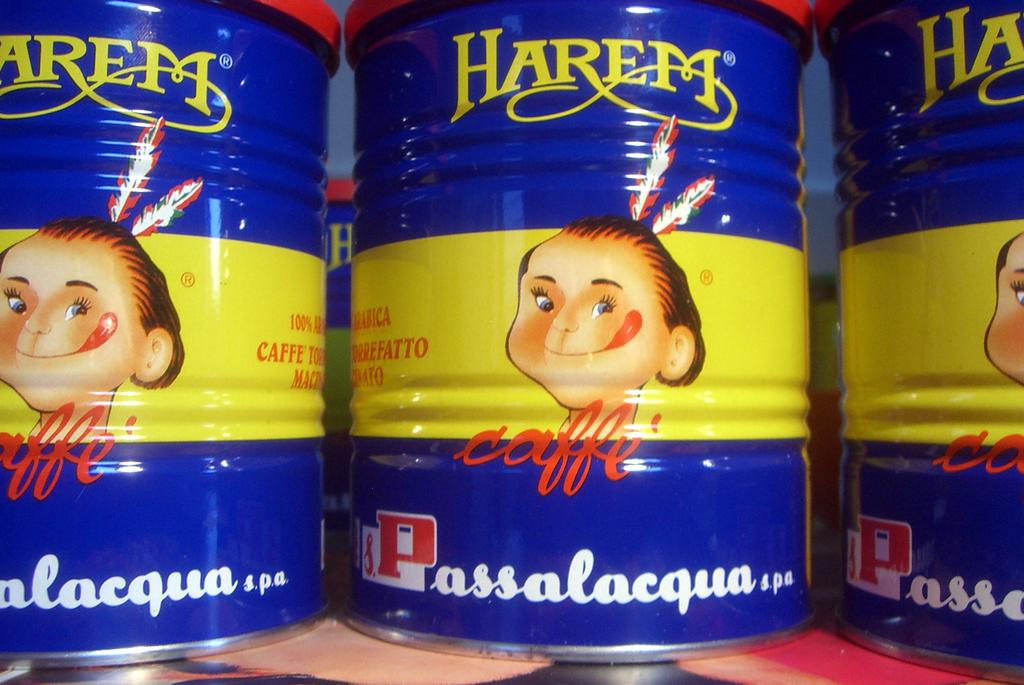<image>
Share a concise interpretation of the image provided. cans of harem caffe passalacqua next to one another 